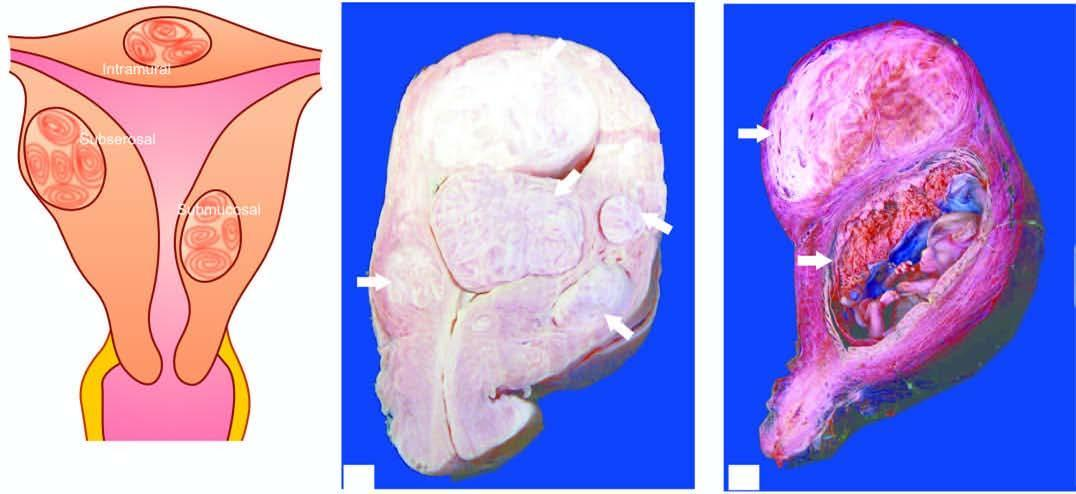does various types of epithelial cells show an intrauterine gestation sac with placenta having grey-white whorled pattern?
Answer the question using a single word or phrase. No 